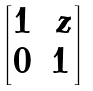Convert formula to latex. <formula><loc_0><loc_0><loc_500><loc_500>\begin{bmatrix} 1 & \, z \\ 0 & 1 \end{bmatrix}</formula> 